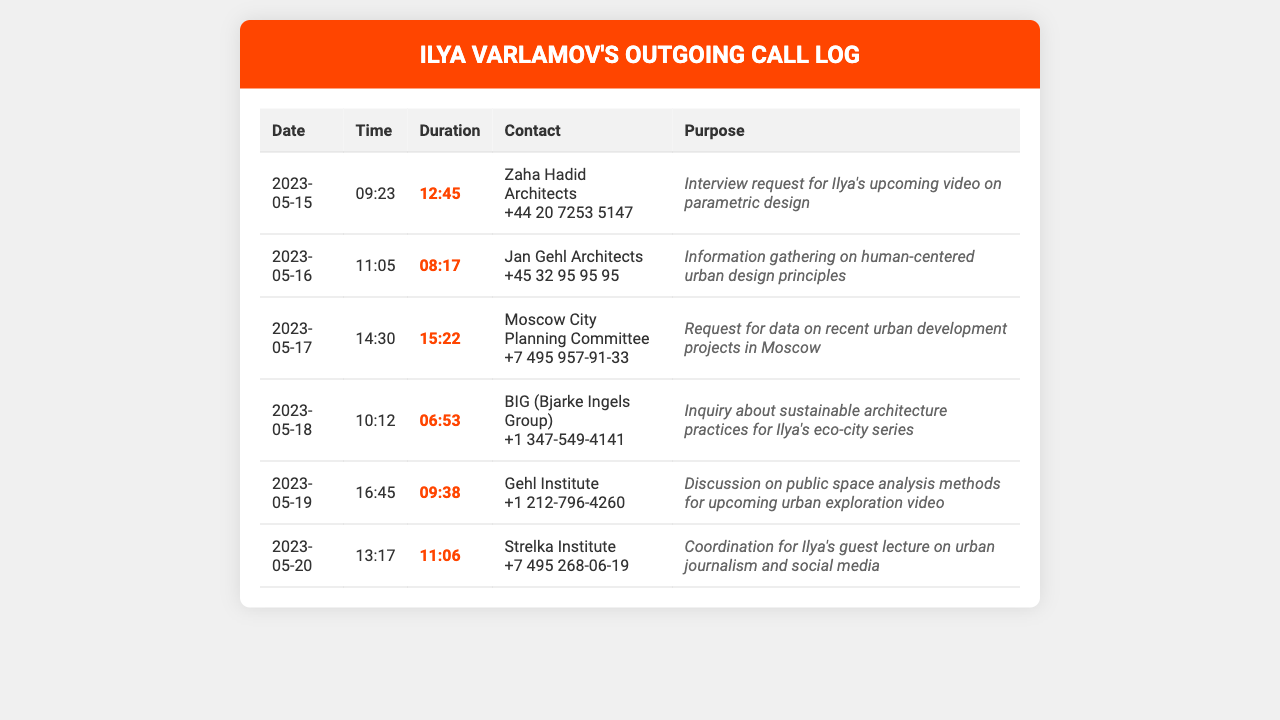What is the duration of the call with Zaha Hadid Architects? The duration is clearly stated in the call record for Zaha Hadid Architects as 12:45.
Answer: 12:45 What is the date of the call with the Moscow City Planning Committee? The record shows the call with the Moscow City Planning Committee occurred on 2023-05-17.
Answer: 2023-05-17 Who did Ilya call to discuss sustainable architecture practices? The call record indicates Ilya called BIG (Bjarke Ingels Group) for this discussion.
Answer: BIG (Bjarke Ingels Group) How long was the call with the Gehl Institute? The duration of the call with the Gehl Institute is listed as 09:38.
Answer: 09:38 What is the main purpose of the call with Jan Gehl Architects? The document specifies that the call's purpose was to gather information on human-centered urban design principles.
Answer: Information gathering on human-centered urban design principles Which organization did Ilya contact on May 20th? The record shows that on May 20th, Ilya contacted the Strelka Institute.
Answer: Strelka Institute How many calls were made on the dates from May 15 to May 20? Counting the entries, there are a total of six calls made during this period.
Answer: 6 What time did the call with BIG begin? The time recorded for the call with BIG was 10:12.
Answer: 10:12 What is a unique feature of this document type? This document provides records of outgoing calls, detailing dates, times, durations, contacts, and purposes.
Answer: Outgoing calls detalied 